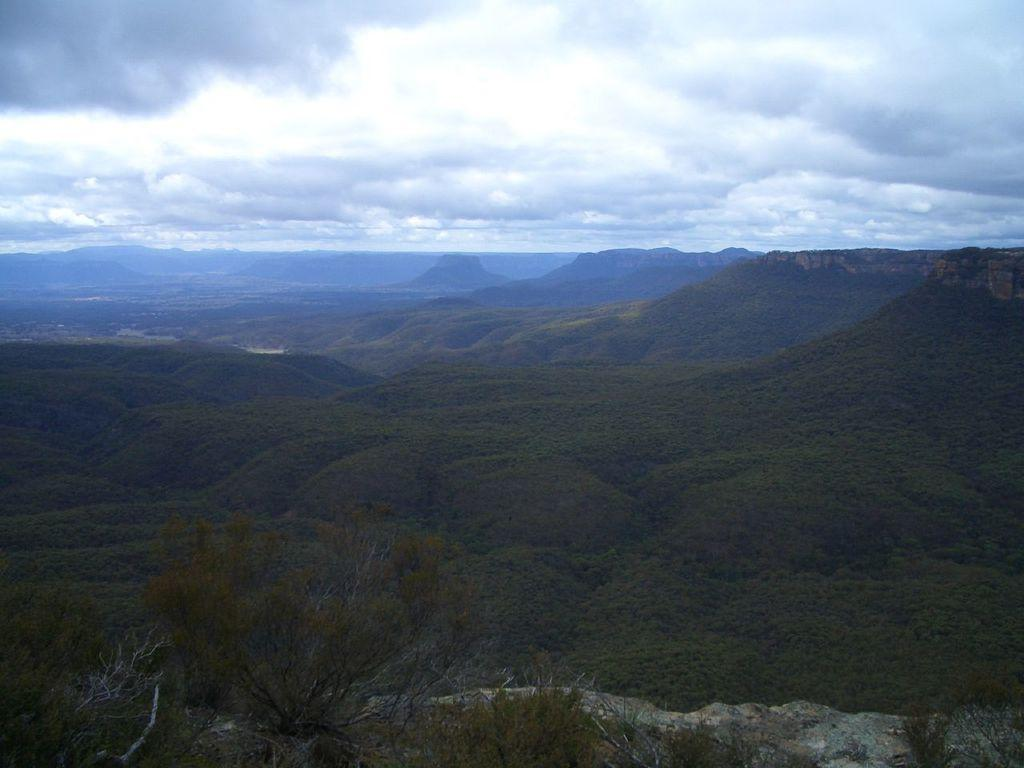What type of vegetation can be seen in the image? There are trees in the image. What type of landscape feature is present in the image? There are hills in the image. What is visible in the background of the image? There is a sky visible in the background of the image. What can be seen in the sky? There are clouds in the sky. What type of condition or regret is expressed by the trees in the image? There is no indication of any condition or regret being expressed by the trees in the image. Are there any bears visible in the image? There are no bears present in the image. 